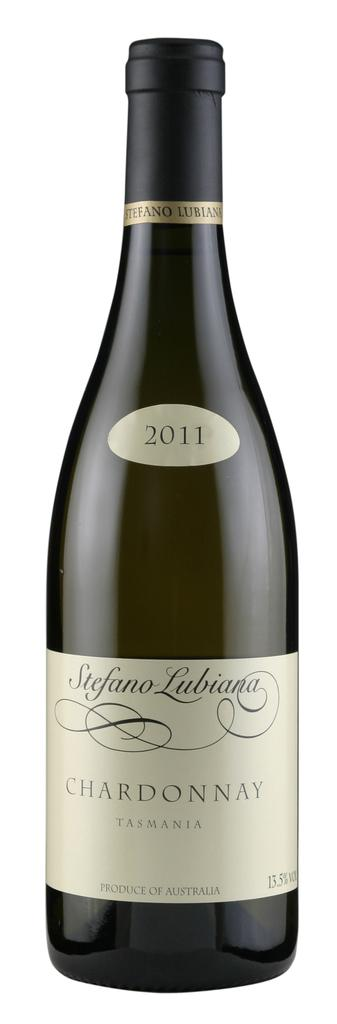<image>
Write a terse but informative summary of the picture. A bottle of Stefano Lubiana Chardonnay from 2011. 